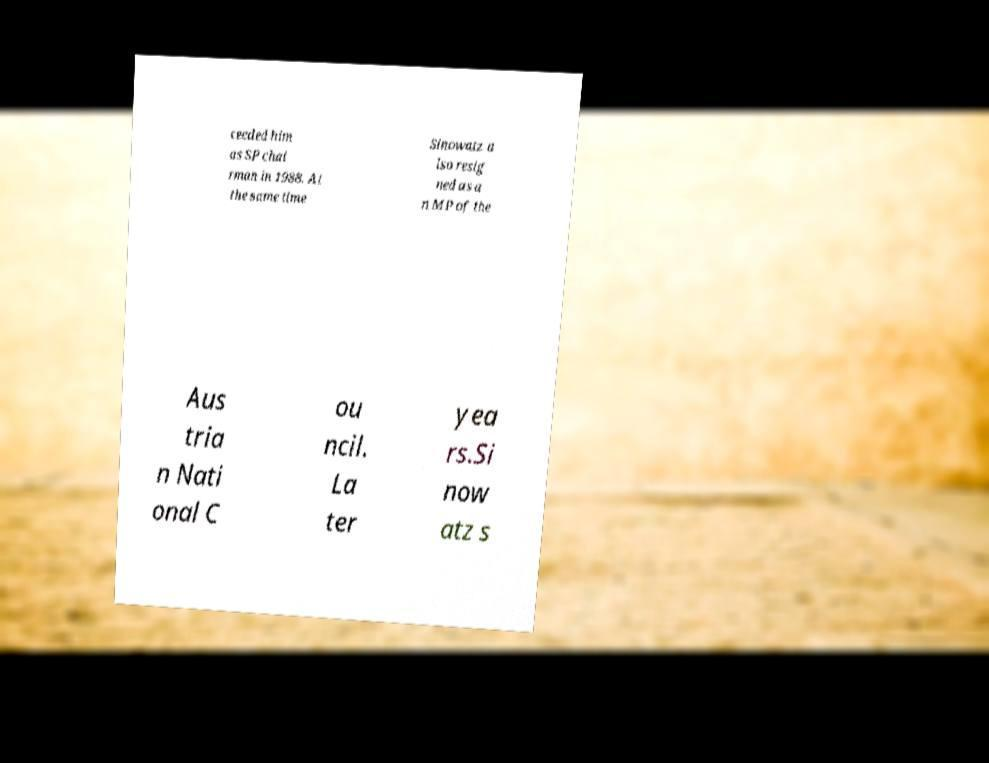There's text embedded in this image that I need extracted. Can you transcribe it verbatim? ceeded him as SP chai rman in 1988. At the same time Sinowatz a lso resig ned as a n MP of the Aus tria n Nati onal C ou ncil. La ter yea rs.Si now atz s 